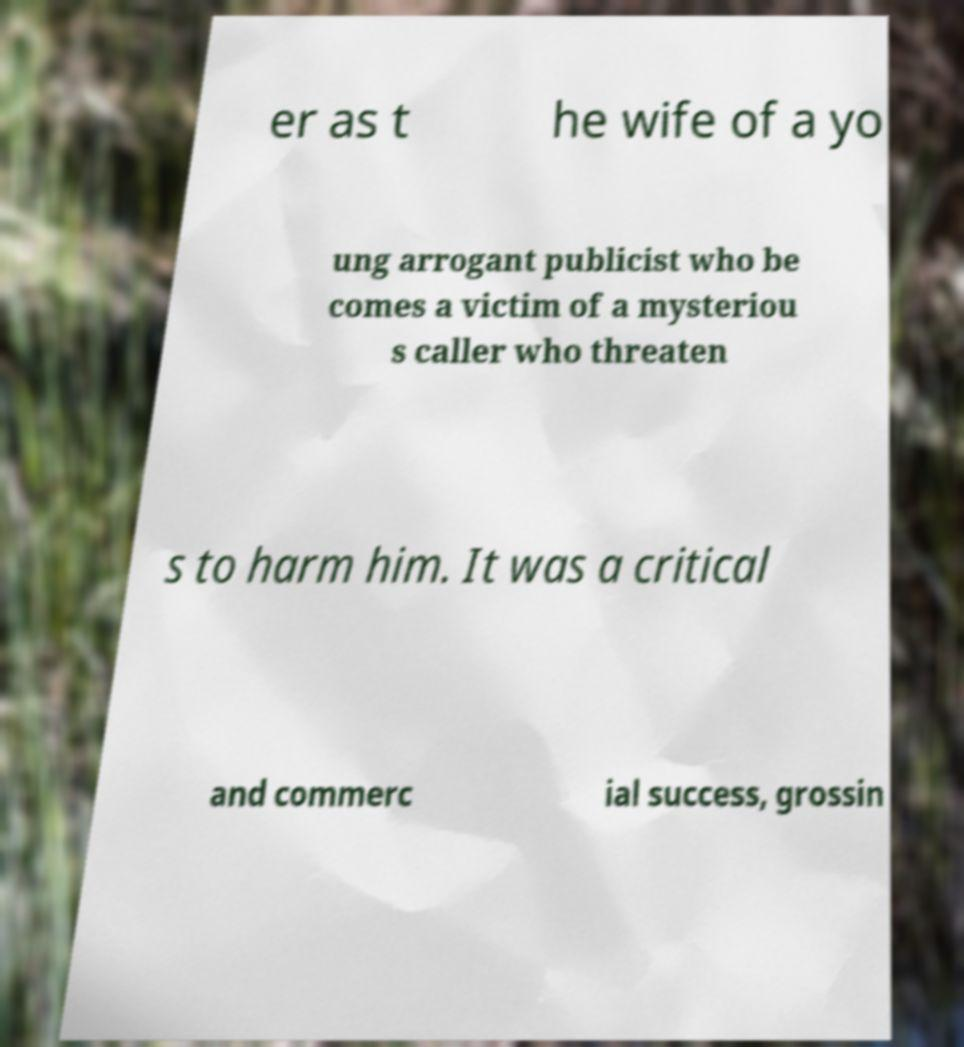I need the written content from this picture converted into text. Can you do that? er as t he wife of a yo ung arrogant publicist who be comes a victim of a mysteriou s caller who threaten s to harm him. It was a critical and commerc ial success, grossin 